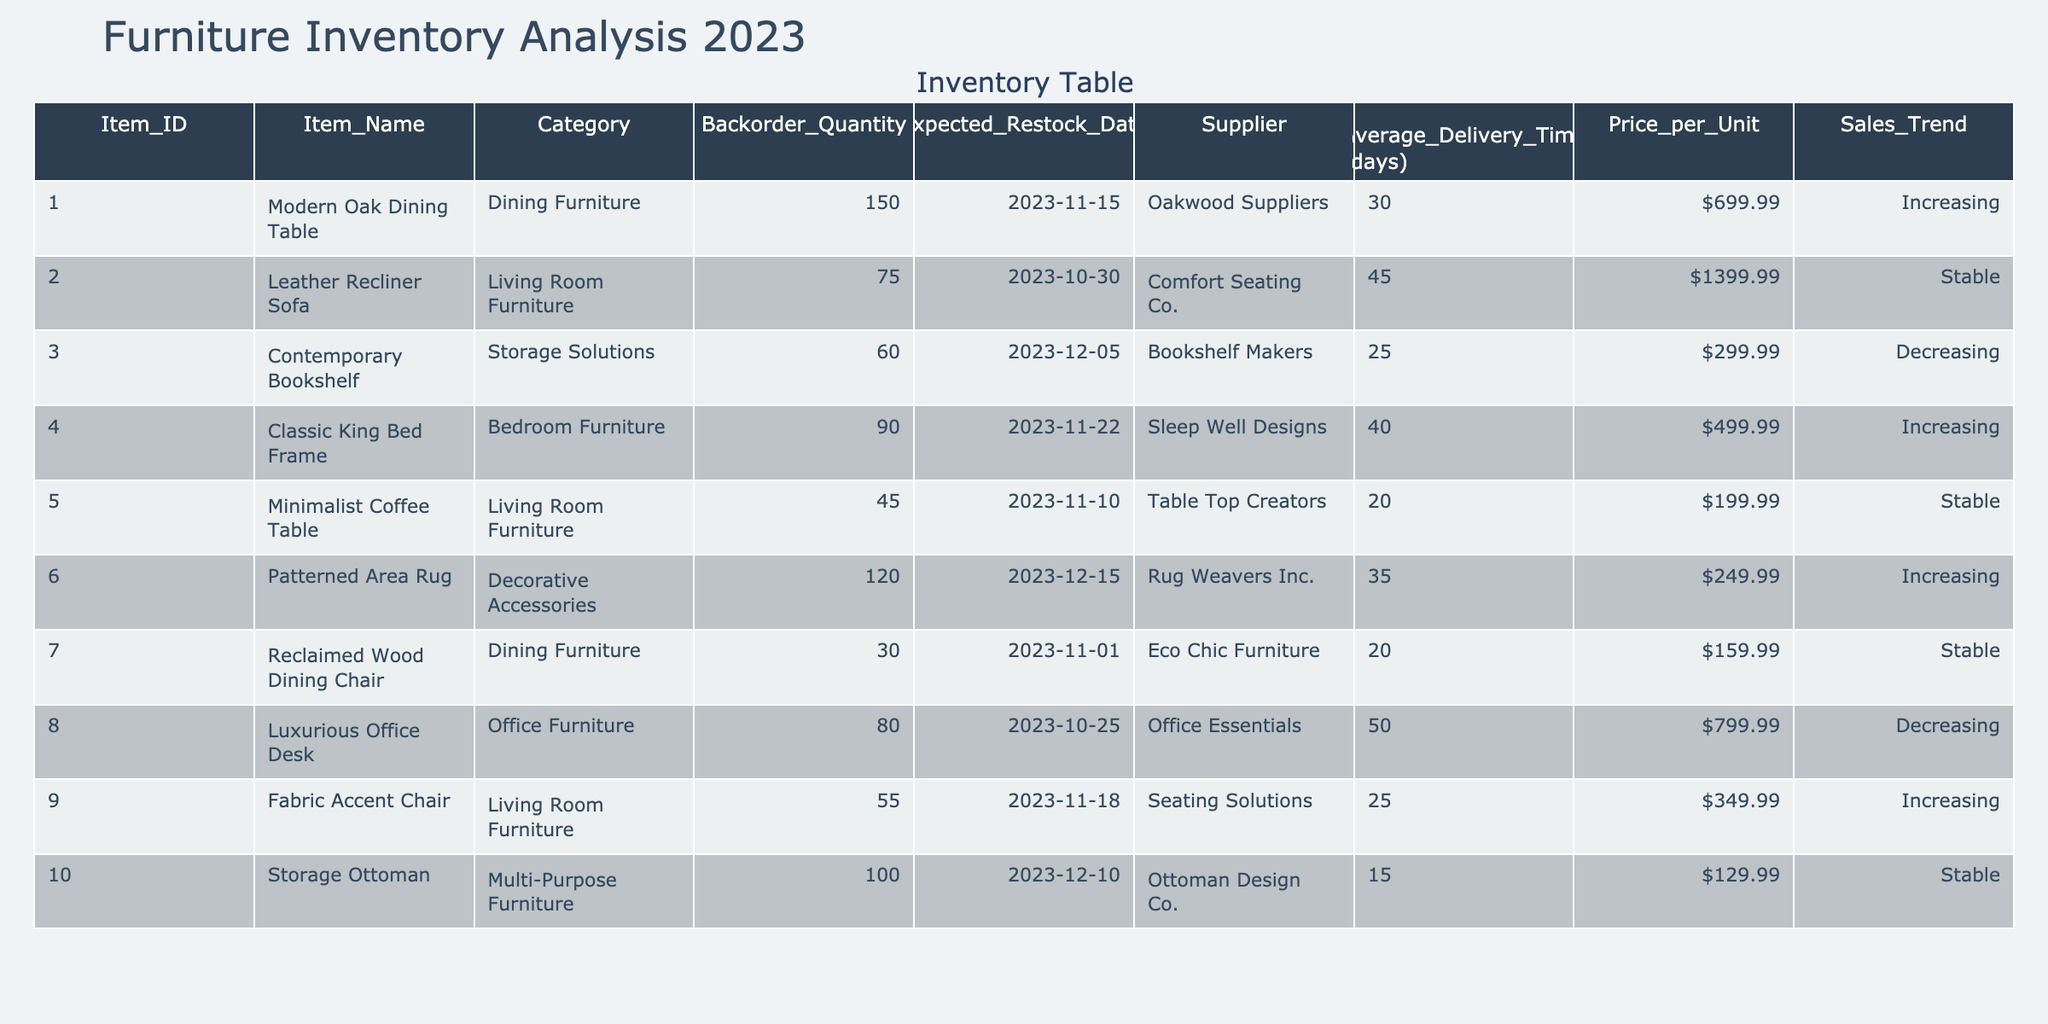What item has the highest backorder quantity? By examining the 'Backorder_Quantity' column, I find that the item with Item_ID 001, the "Modern Oak Dining Table," has 150 units on backorder, which is the highest among all items listed.
Answer: Modern Oak Dining Table Which item has the shortest average delivery time? Looking at the 'Average_Delivery_Time (days)' column, the "Storage Ottoman" has the shortest delivery time of 15 days, making it the item that can be delivered the quickest.
Answer: Storage Ottoman Is the "Leather Recliner Sofa" expected to be restocked before November 1, 2023? The expected restock date for the "Leather Recliner Sofa" is October 30, 2023, which is indeed before November 1, 2023.
Answer: Yes What is the total backorder quantity for all dining furniture items? The backorder quantities for dining furniture items ("Modern Oak Dining Table" and "Reclaimed Wood Dining Chair") are 150 and 30, respectively. Summing these gives 150 + 30 = 180.
Answer: 180 Which item in the storage solutions category has the highest price per unit? From the "Storage Solutions" category, the "Contemporary Bookshelf" priced at $299.99 is the only item listed in that category; therefore, it has the highest price per unit by default.
Answer: Contemporary Bookshelf Are there more items with an increasing sales trend or a decreasing sales trend? Analyzing the 'Sales_Trend' column, there are four items with an "Increasing" trend (items 001, 004, 006, 009) and two items with a "Decreasing" trend (items 003, 008), indicating that there are more items with an increasing trend.
Answer: More items with increasing sales trend What is the average price per unit for all furniture items? I calculate the average price by summing all the price per unit values: 699.99 + 1399.99 + 299.99 + 499.99 + 199.99 + 249.99 + 159.99 + 799.99 + 349.99 + 129.99 = 4289.90. There are 10 items, so the average price per unit is 4289.90 / 10 = 428.99.
Answer: 428.99 